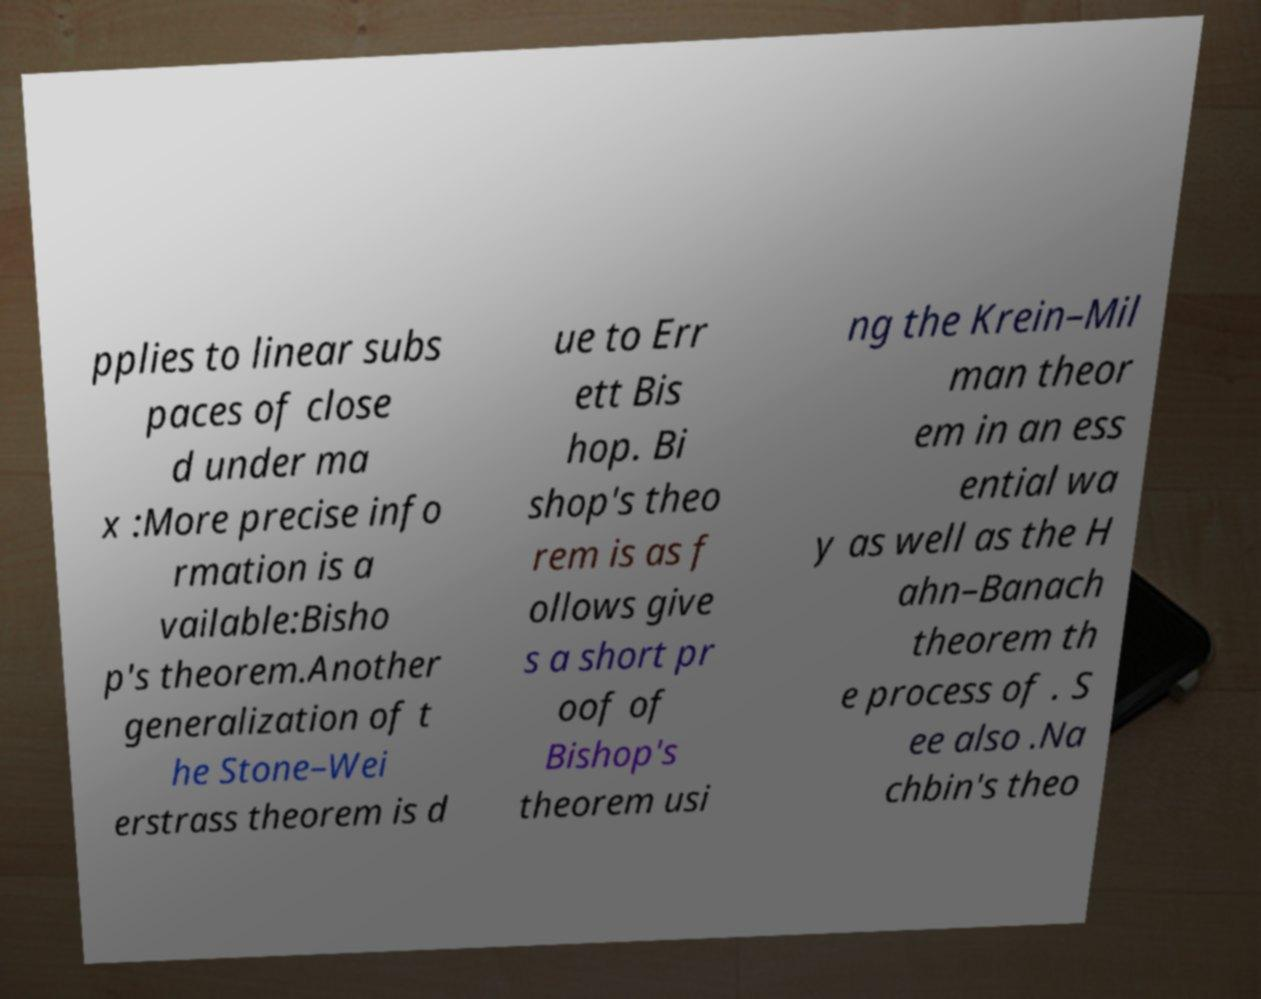Please identify and transcribe the text found in this image. pplies to linear subs paces of close d under ma x :More precise info rmation is a vailable:Bisho p's theorem.Another generalization of t he Stone–Wei erstrass theorem is d ue to Err ett Bis hop. Bi shop's theo rem is as f ollows give s a short pr oof of Bishop's theorem usi ng the Krein–Mil man theor em in an ess ential wa y as well as the H ahn–Banach theorem th e process of . S ee also .Na chbin's theo 